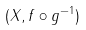Convert formula to latex. <formula><loc_0><loc_0><loc_500><loc_500>( X , f \circ g ^ { - 1 } )</formula> 